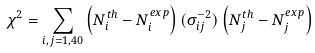<formula> <loc_0><loc_0><loc_500><loc_500>\chi ^ { 2 } = \sum _ { i , j = 1 , 4 0 } \left ( N _ { i } ^ { t h } - N _ { i } ^ { e x p } \right ) ( \sigma _ { i j } ^ { - 2 } ) \left ( N _ { j } ^ { t h } - N _ { j } ^ { e x p } \right )</formula> 